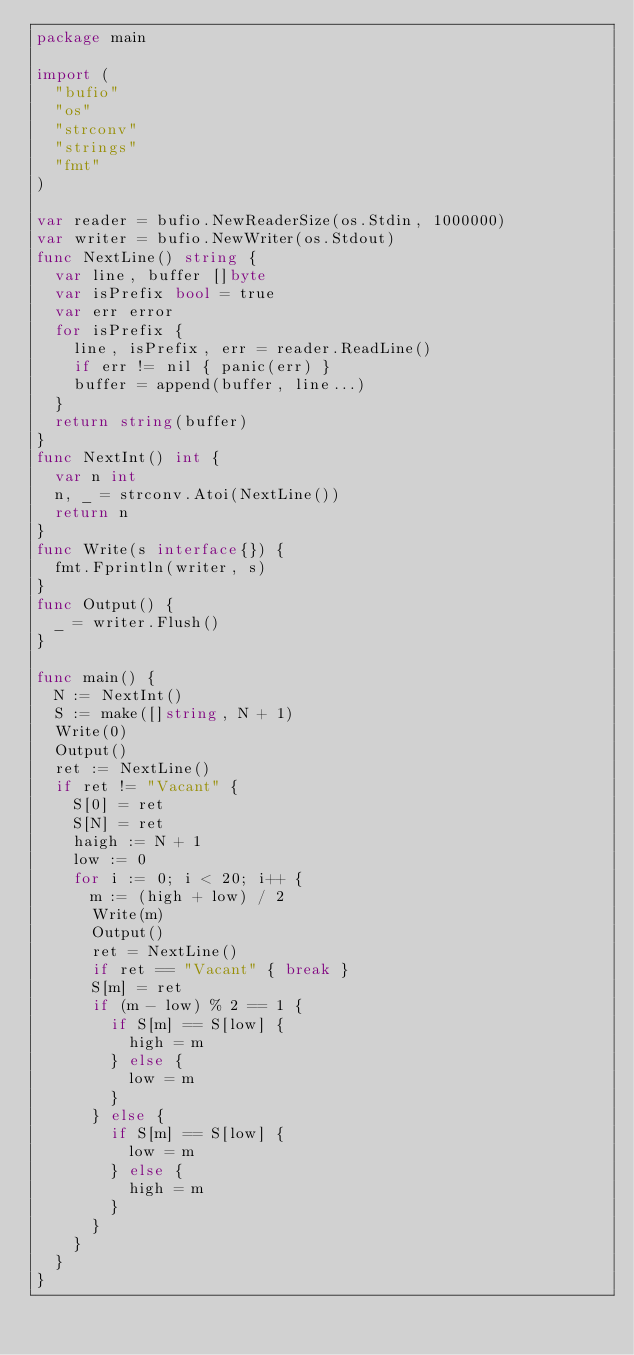Convert code to text. <code><loc_0><loc_0><loc_500><loc_500><_Go_>package main

import (
  "bufio"
  "os"
  "strconv"
  "strings"
  "fmt"
)

var reader = bufio.NewReaderSize(os.Stdin, 1000000)
var writer = bufio.NewWriter(os.Stdout)
func NextLine() string {
  var line, buffer []byte
  var isPrefix bool = true
  var err error
  for isPrefix {
    line, isPrefix, err = reader.ReadLine()
    if err != nil { panic(err) }
    buffer = append(buffer, line...)
  }
  return string(buffer)
}
func NextInt() int {
  var n int
  n, _ = strconv.Atoi(NextLine())
  return n
}
func Write(s interface{}) {
  fmt.Fprintln(writer, s)
}
func Output() {
  _ = writer.Flush()
}

func main() {
  N := NextInt()
  S := make([]string, N + 1)
  Write(0)
  Output()
  ret := NextLine()
  if ret != "Vacant" {
    S[0] = ret
    S[N] = ret
    haigh := N + 1
    low := 0
    for i := 0; i < 20; i++ {
      m := (high + low) / 2
      Write(m)
      Output()
      ret = NextLine()
      if ret == "Vacant" { break }
      S[m] = ret
      if (m - low) % 2 == 1 {
        if S[m] == S[low] {
          high = m
        } else {
          low = m
        }
      } else {
        if S[m] == S[low] {
          low = m
        } else {
          high = m
        }
      }
    }
  }
}</code> 